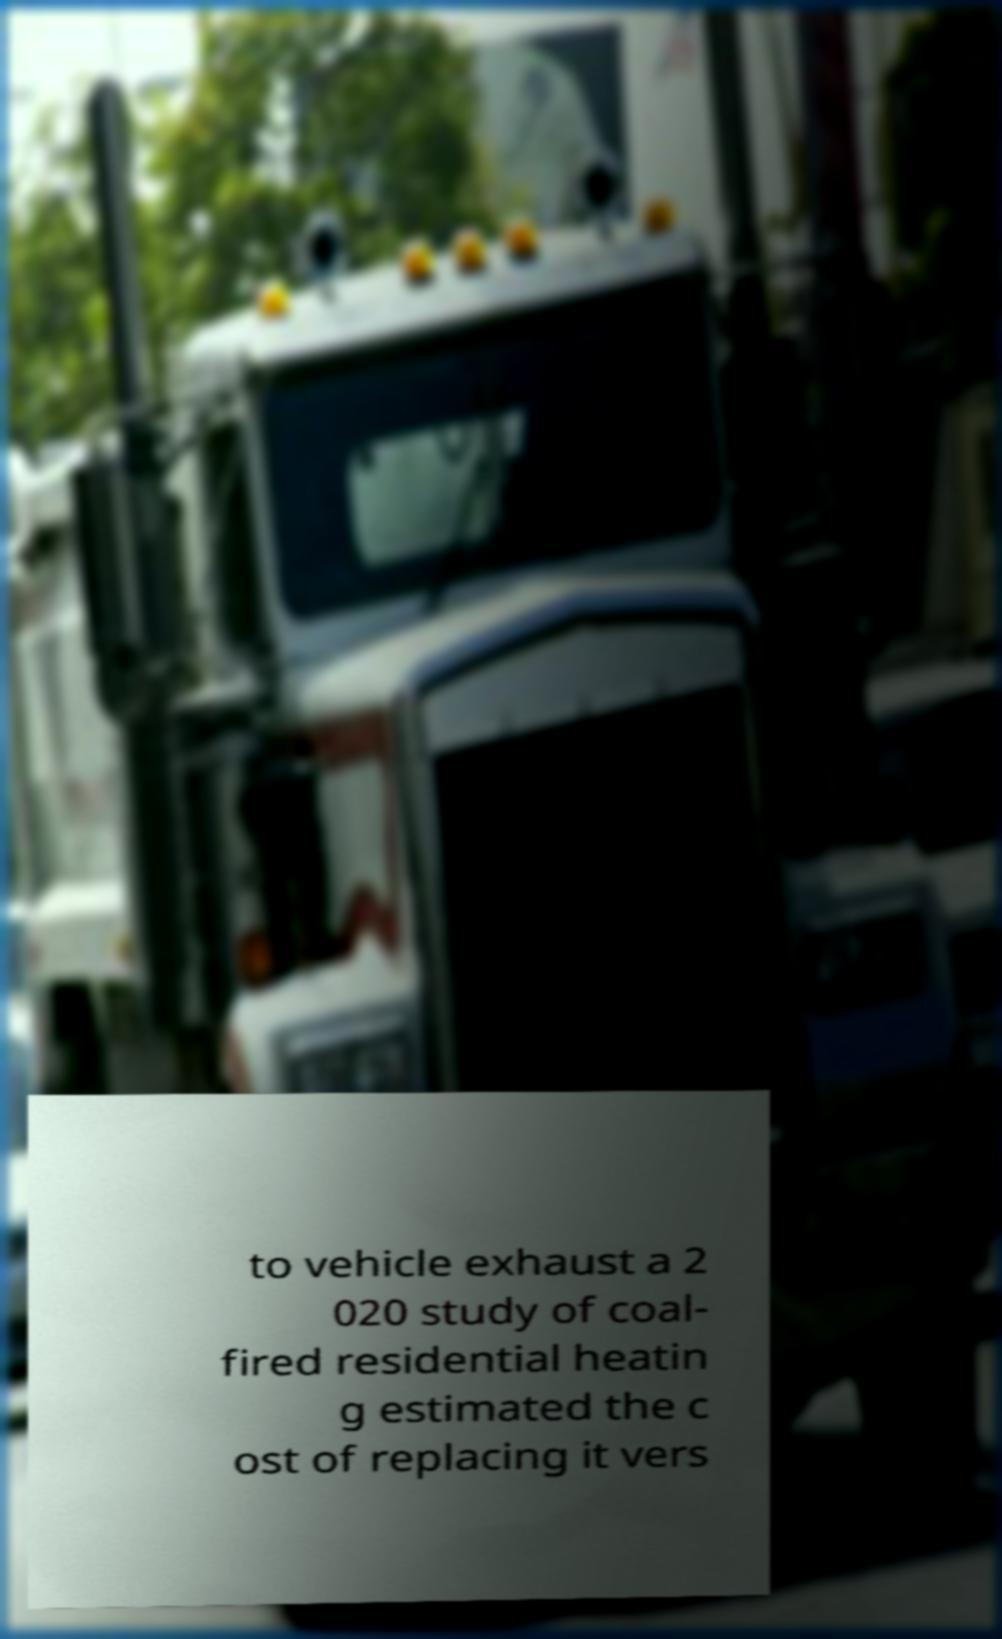Can you accurately transcribe the text from the provided image for me? to vehicle exhaust a 2 020 study of coal- fired residential heatin g estimated the c ost of replacing it vers 